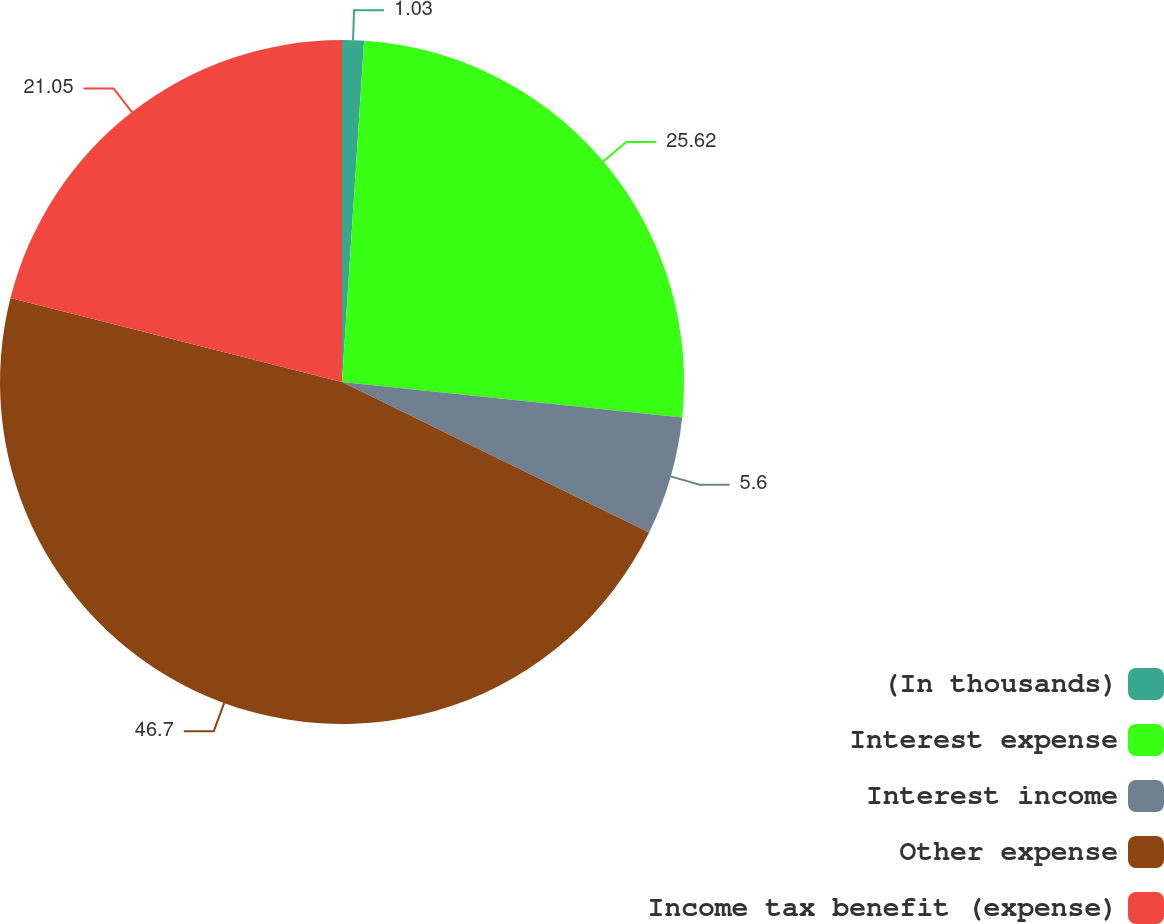Convert chart. <chart><loc_0><loc_0><loc_500><loc_500><pie_chart><fcel>(In thousands)<fcel>Interest expense<fcel>Interest income<fcel>Other expense<fcel>Income tax benefit (expense)<nl><fcel>1.03%<fcel>25.62%<fcel>5.6%<fcel>46.7%<fcel>21.05%<nl></chart> 